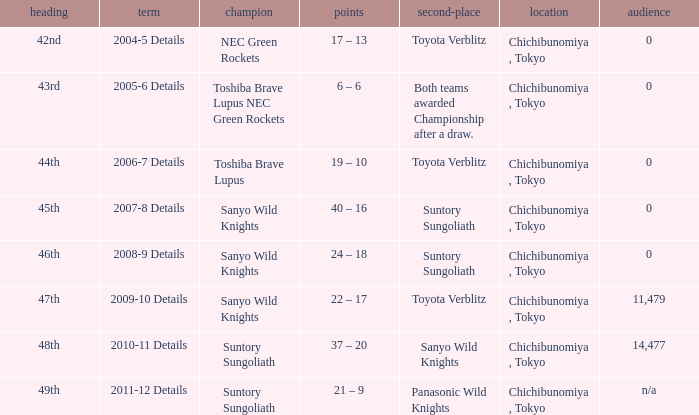What team was the winner when the runner-up shows both teams awarded championship after a draw.? Toshiba Brave Lupus NEC Green Rockets. 